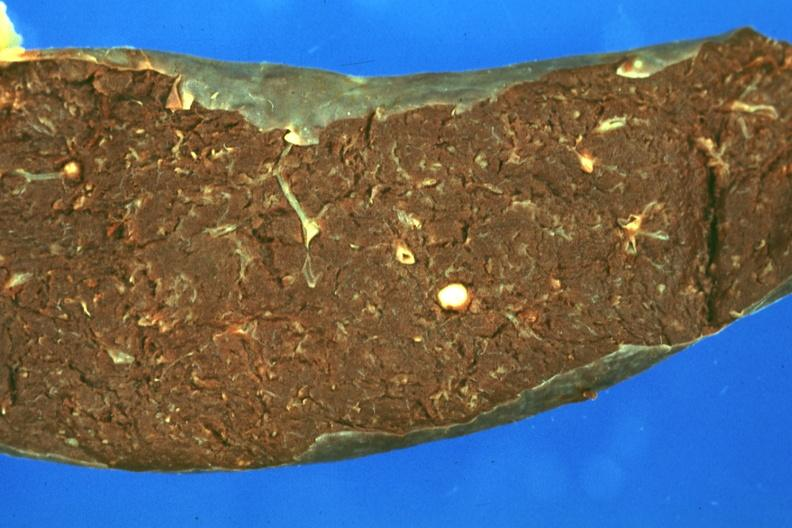s opened base of skull with brain present?
Answer the question using a single word or phrase. No 